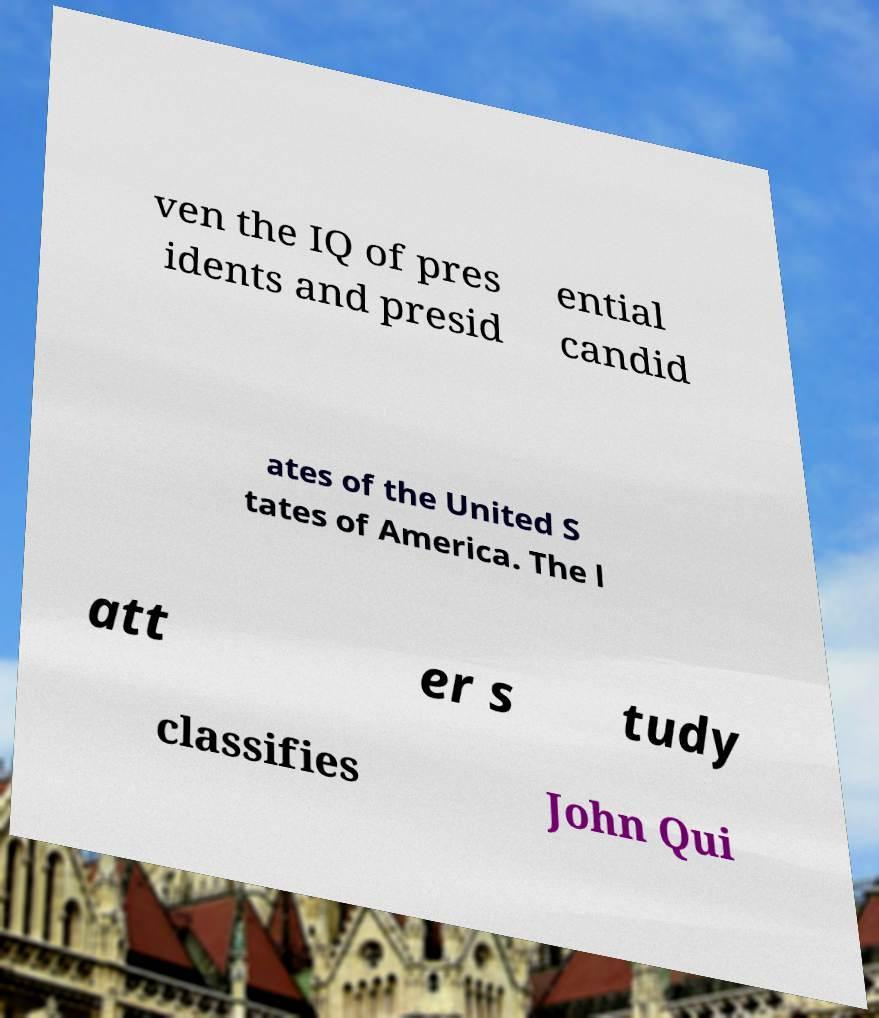Can you read and provide the text displayed in the image?This photo seems to have some interesting text. Can you extract and type it out for me? ven the IQ of pres idents and presid ential candid ates of the United S tates of America. The l att er s tudy classifies John Qui 